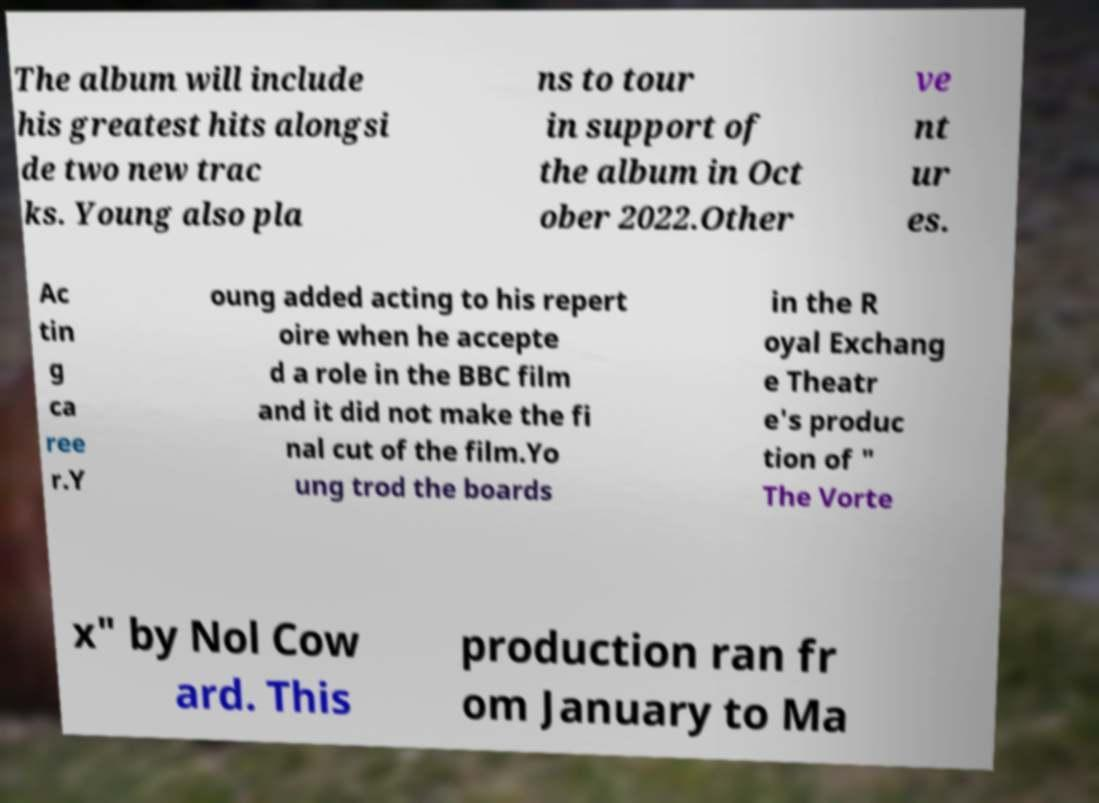There's text embedded in this image that I need extracted. Can you transcribe it verbatim? The album will include his greatest hits alongsi de two new trac ks. Young also pla ns to tour in support of the album in Oct ober 2022.Other ve nt ur es. Ac tin g ca ree r.Y oung added acting to his repert oire when he accepte d a role in the BBC film and it did not make the fi nal cut of the film.Yo ung trod the boards in the R oyal Exchang e Theatr e's produc tion of " The Vorte x" by Nol Cow ard. This production ran fr om January to Ma 